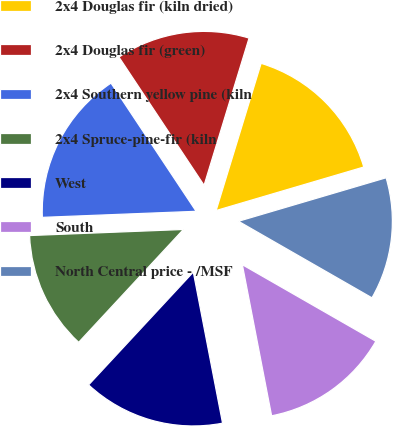Convert chart. <chart><loc_0><loc_0><loc_500><loc_500><pie_chart><fcel>2x4 Douglas fir (kiln dried)<fcel>2x4 Douglas fir (green)<fcel>2x4 Southern yellow pine (kiln<fcel>2x4 Spruce-pine-fir (kiln<fcel>West<fcel>South<fcel>North Central price - /MSF<nl><fcel>15.72%<fcel>14.05%<fcel>16.3%<fcel>12.47%<fcel>14.95%<fcel>13.67%<fcel>12.85%<nl></chart> 